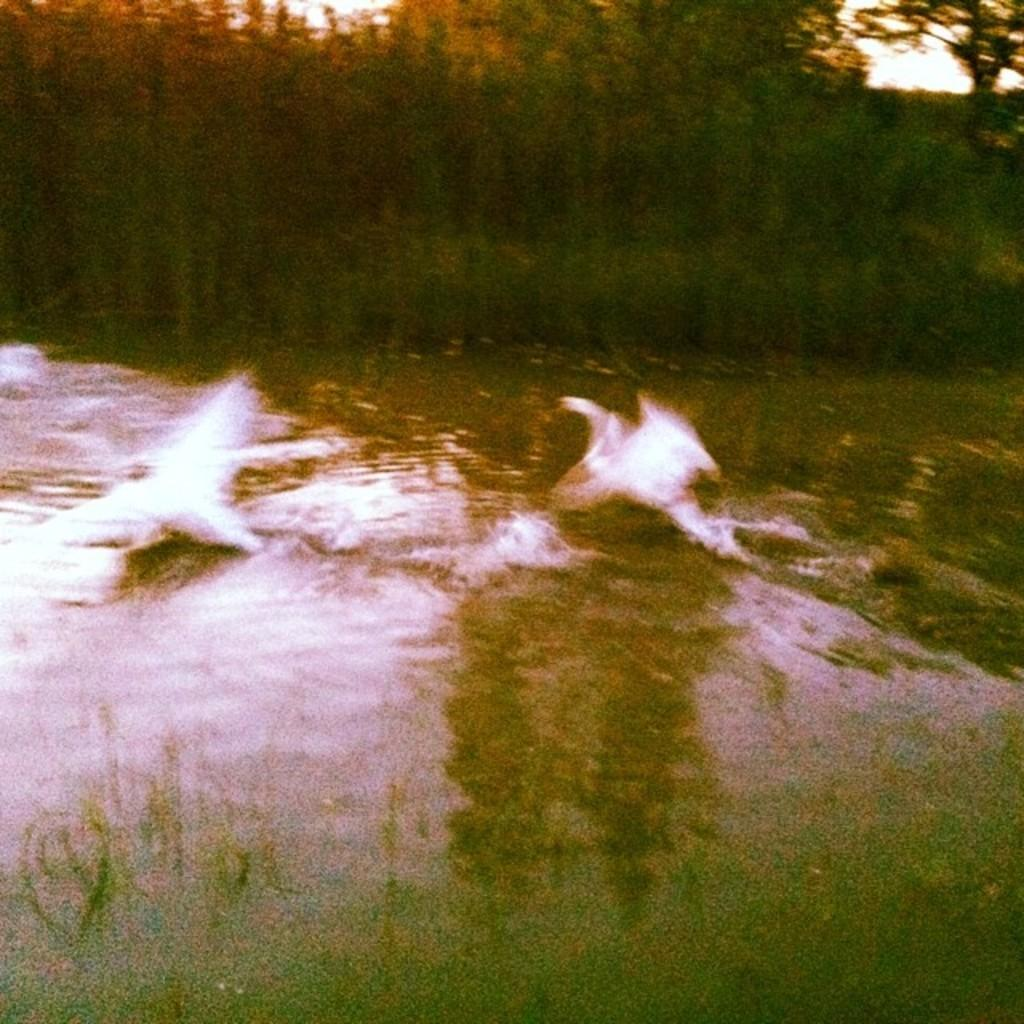What is the main feature in the center of the image? There is a lake in the center of the image. What can be seen in the background of the image? There are trees in the background of the image. What is present in the lake? There are objects in the lake, which appear to be fishes. What type of canvas is being used to create the image? The image is not a painting or artwork, so there is no canvas involved in its creation. 